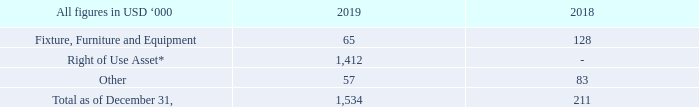8. OTHER NON-CURRENT ASSETS
* relates to certain office lease contracts. Optional periods are not included in the calculation.
What does the Right of Use Asset refer to? Relates to certain office lease contracts. What are the respective values of the company's fixture, furniture and equipment in 2018 and 2019?
Answer scale should be: thousand. 128, 65. What are the respective values of the company's other non-current assets in 2018 and 2019?
Answer scale should be: thousand. 83, 57. What is the average other non-current assets as at December 31, 2018 and 2019?
Answer scale should be: thousand. (83 + 57)/2
Answer: 70. What is the change in Fixture, Furniture and Equipment between 2018 and 2019?
Answer scale should be: thousand. 128-65
Answer: 63. What is the value of the other non-current assets as at December 31, 2018 as a percentage of the value of other non-current assets in 2019?
Answer scale should be: percent. 83/57 
Answer: 145.61. 